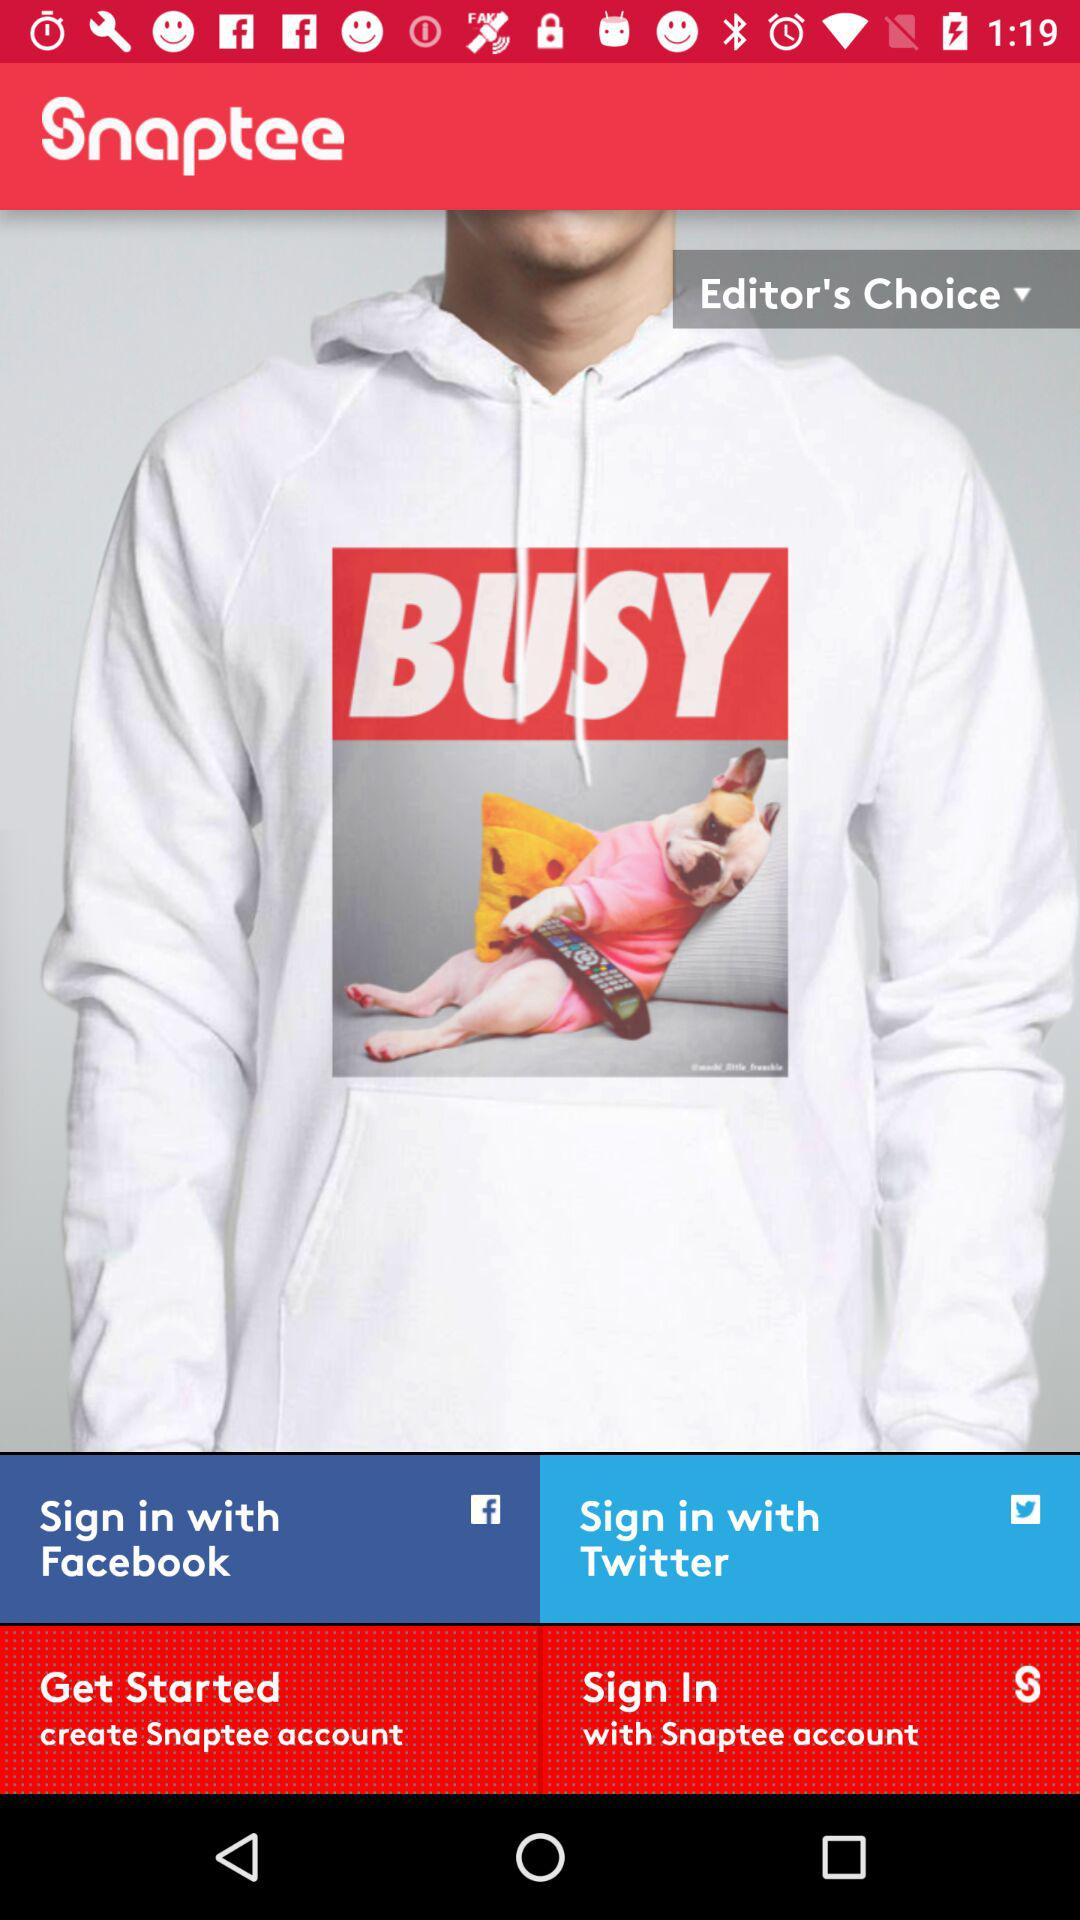What is the app name? The name of the app is "Snaptee". 